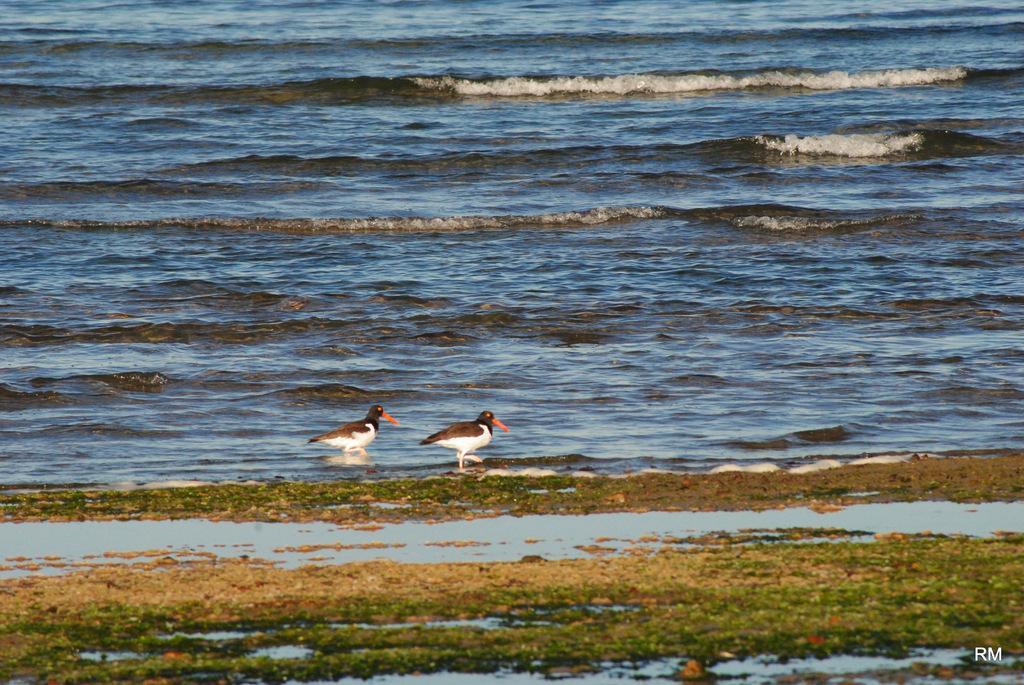How would you summarize this image in a sentence or two? This image is taken outdoors. At the bottom of the image there is a ground with grass on it. In the middle of the image there is a sea with waves and there are two birds on the ground. 